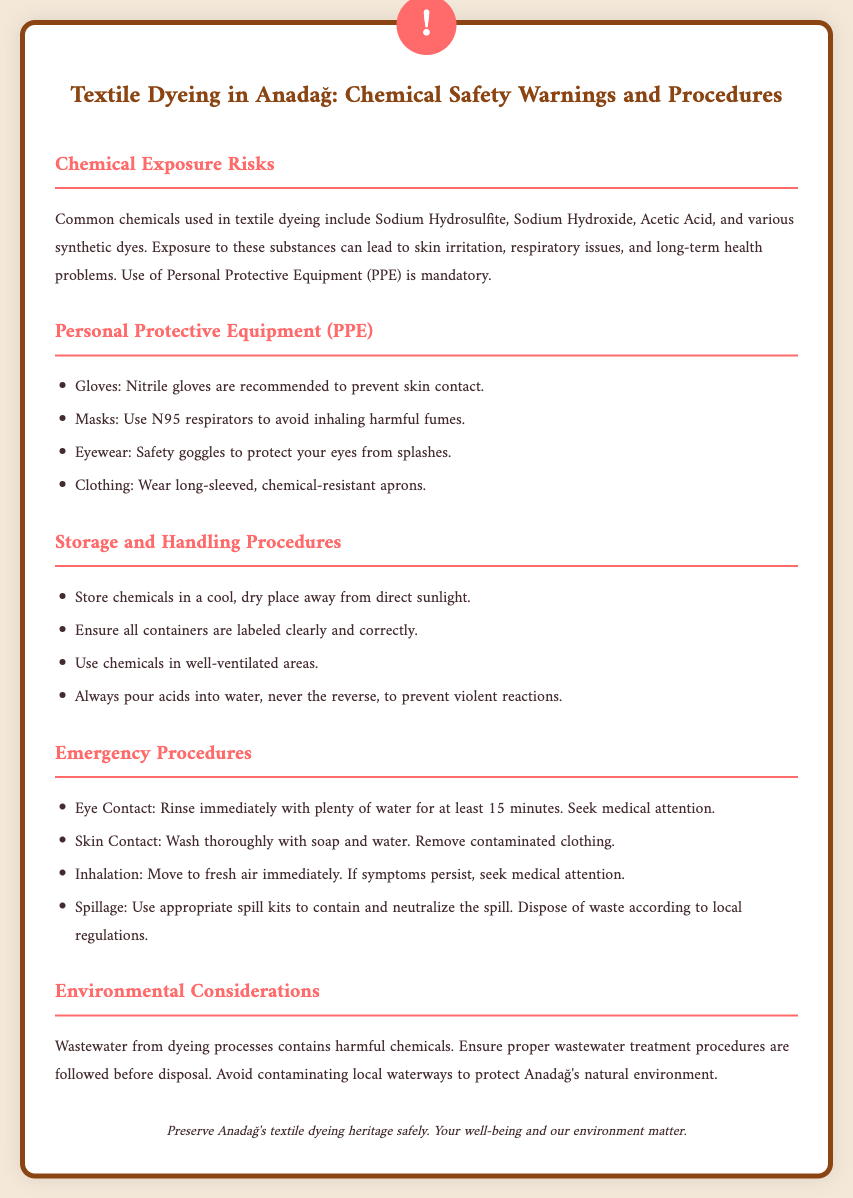what chemicals are commonly used in textile dyeing? The document lists Sodium Hydrosulfite, Sodium Hydroxide, Acetic Acid, and various synthetic dyes as common chemicals used.
Answer: Sodium Hydrosulfite, Sodium Hydroxide, Acetic Acid, synthetic dyes what type of gloves are recommended? The document specifies that nitrile gloves are recommended to prevent skin contact.
Answer: Nitrile gloves what should you do in case of eye contact? The emergency procedures state to rinse the eyes immediately with plenty of water for at least 15 minutes.
Answer: Rinse with plenty of water for at least 15 minutes where should chemicals be stored? The document advises storing chemicals in a cool, dry place away from direct sunlight.
Answer: Cool, dry place away from direct sunlight how should acids be poured? It is mentioned to always pour acids into water, never the reverse, to prevent violent reactions.
Answer: Pour acids into water what is a key environmental consideration? The document emphasizes that wastewater from dyeing processes contains harmful chemicals and proper treatment procedures should be followed.
Answer: Proper wastewater treatment procedures how many PPE items are listed? The document lists four types of PPE items: gloves, masks, eyewear, and clothing.
Answer: Four items what is the main hazard of textile dyeing? The document summarizes that exposure can lead to skin irritation, respiratory issues, and long-term health problems.
Answer: Skin irritation, respiratory issues, long-term health problems 